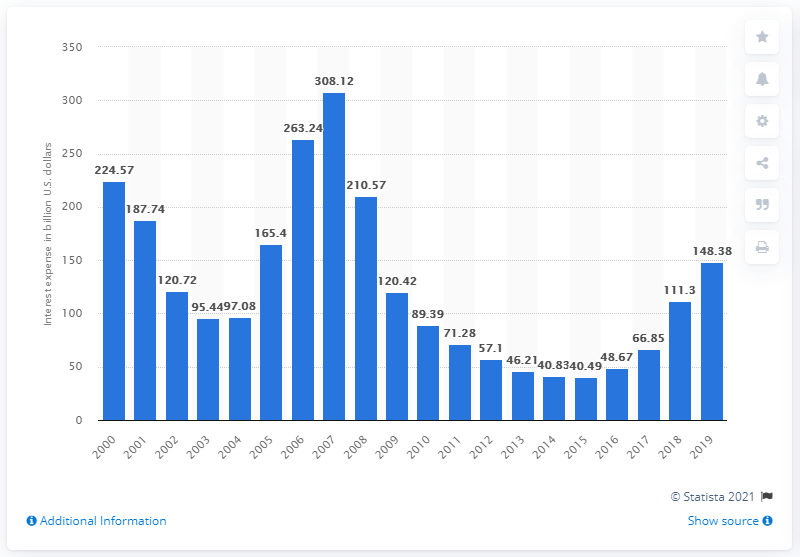Draw attention to some important aspects in this diagram. The interest expense of FDIC-insured commercial banks in the United States in 2019 was 148.38. In 2019, the interest expense of FDIC-insured commercial banks in the United States was $148.38. 